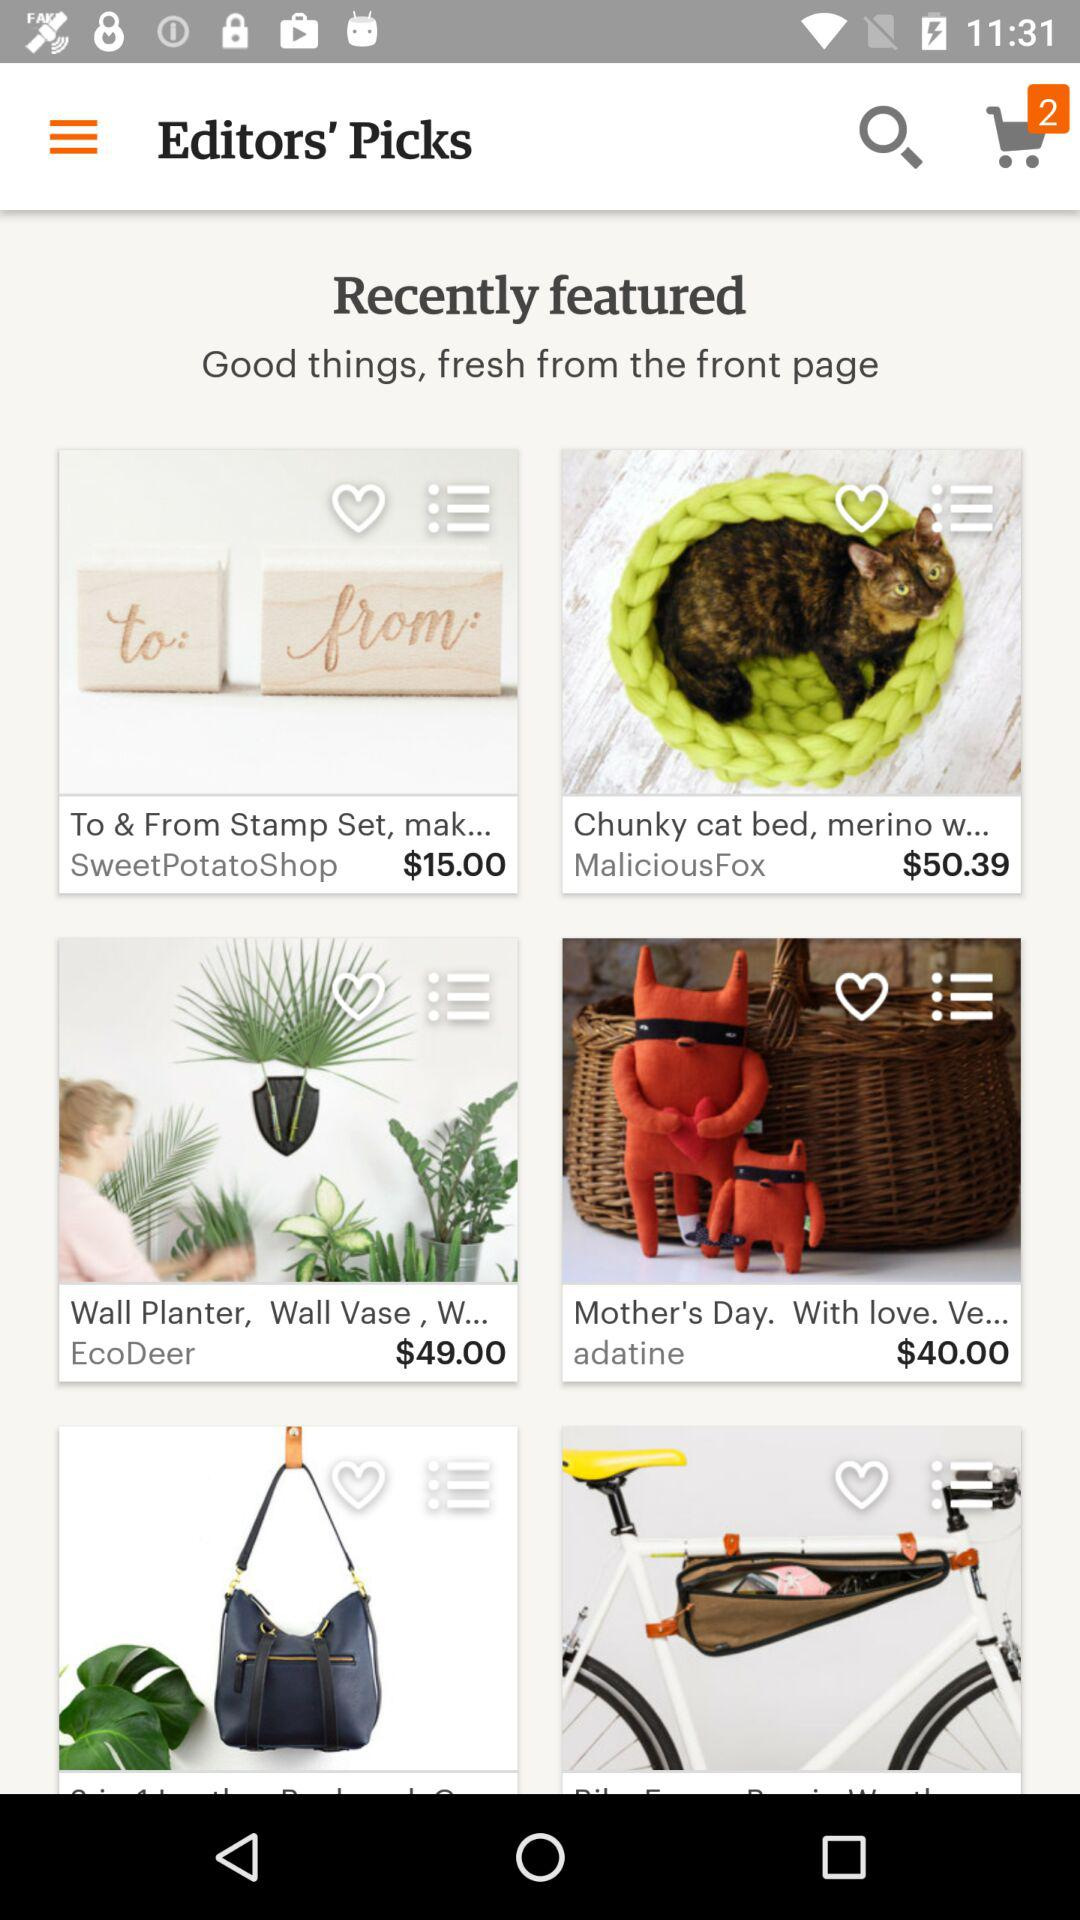How many items are there in the cart? There are 2 items in the cart. 